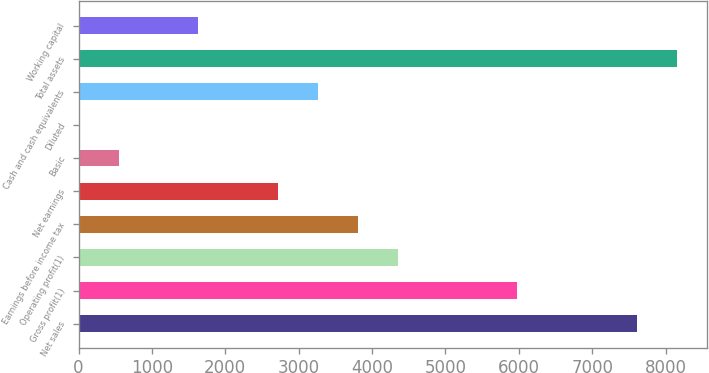Convert chart. <chart><loc_0><loc_0><loc_500><loc_500><bar_chart><fcel>Net sales<fcel>Gross profit(1)<fcel>Operating profit(1)<fcel>Earnings before income tax<fcel>Net earnings<fcel>Basic<fcel>Diluted<fcel>Cash and cash equivalents<fcel>Total assets<fcel>Working capital<nl><fcel>7612.85<fcel>5981.93<fcel>4351.01<fcel>3807.37<fcel>2720.09<fcel>545.53<fcel>1.89<fcel>3263.73<fcel>8156.49<fcel>1632.81<nl></chart> 